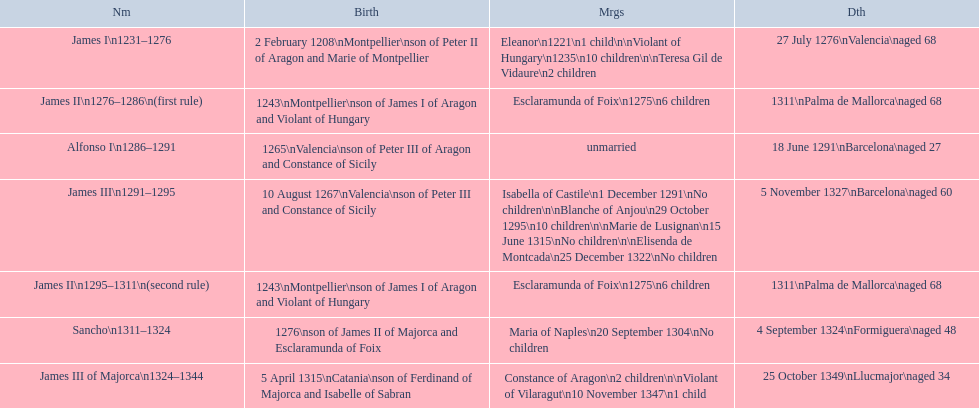How many total marriages did james i have? 3. 